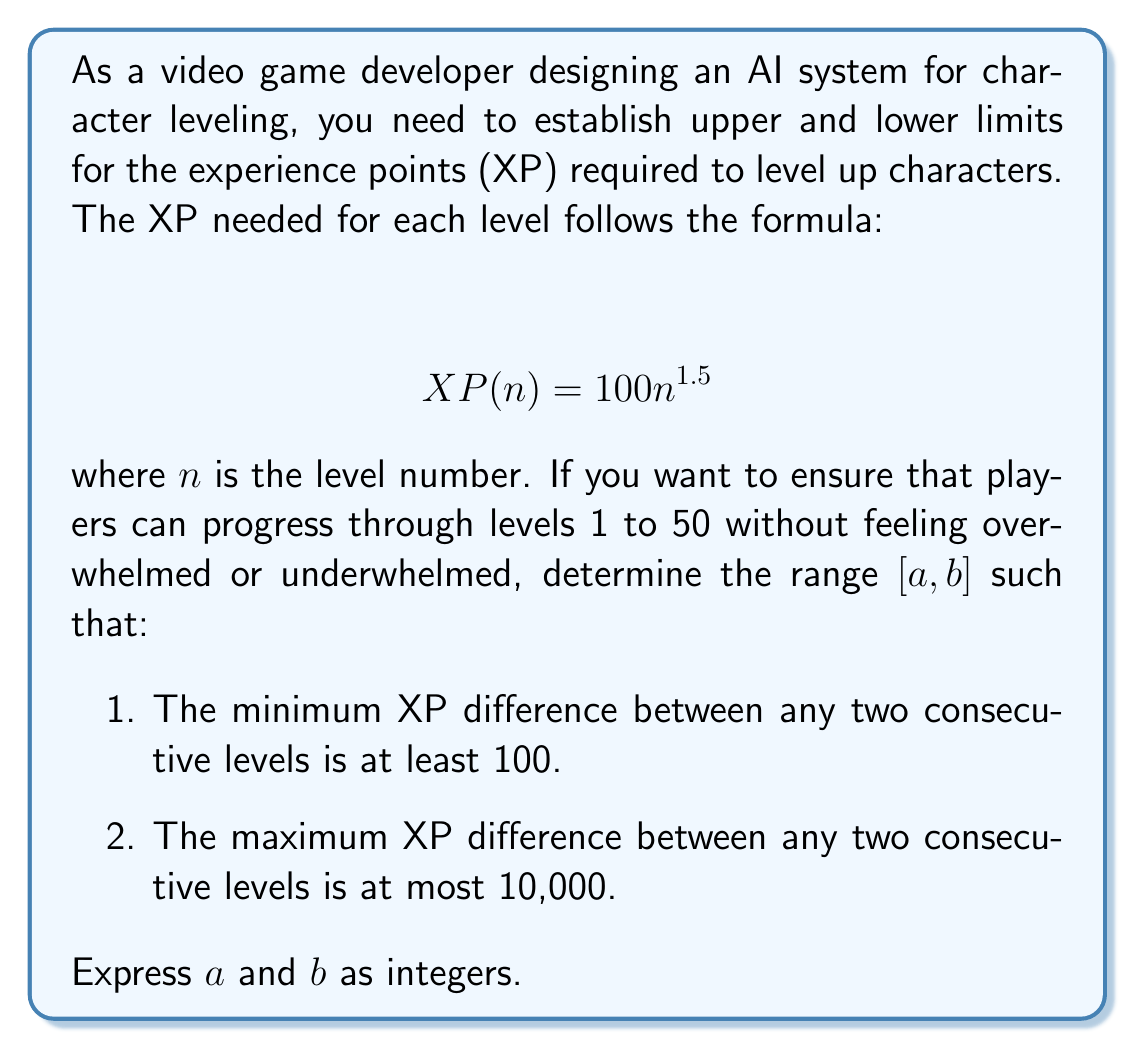Solve this math problem. Let's approach this step-by-step:

1) First, we need to find the XP difference between consecutive levels. For levels $n$ and $n+1$, the difference is:

   $$ \Delta XP(n) = XP(n+1) - XP(n) = 100(n+1)^{1.5} - 100n^{1.5} $$

2) We want this difference to be at least 100 and at most 10,000 for all levels from 1 to 49 (as level 50 is the maximum). So:

   $$ 100 \leq 100(n+1)^{1.5} - 100n^{1.5} \leq 10000 $$

3) Dividing by 100:

   $$ 1 \leq (n+1)^{1.5} - n^{1.5} \leq 100 $$

4) The left inequality (lower bound) is always satisfied for $n \geq 1$, so we only need to focus on the right inequality (upper bound).

5) We need to find the largest $n$ for which:

   $$ (n+1)^{1.5} - n^{1.5} \leq 100 $$

6) This inequality doesn't have a simple algebraic solution, so we can solve it numerically. Using a calculator or computer, we find that the largest $n$ satisfying this inequality is 49.

7) Therefore, our range $[a, b]$ is $[1, 49]$.

8) To verify:
   - For $n=1$: $\Delta XP(1) = 100(2^{1.5} - 1^{1.5}) \approx 182.8$
   - For $n=49$: $\Delta XP(49) = 100(50^{1.5} - 49^{1.5}) \approx 9994.7$

Both of these are within our desired range of [100, 10000].
Answer: $a = 1$, $b = 49$ 